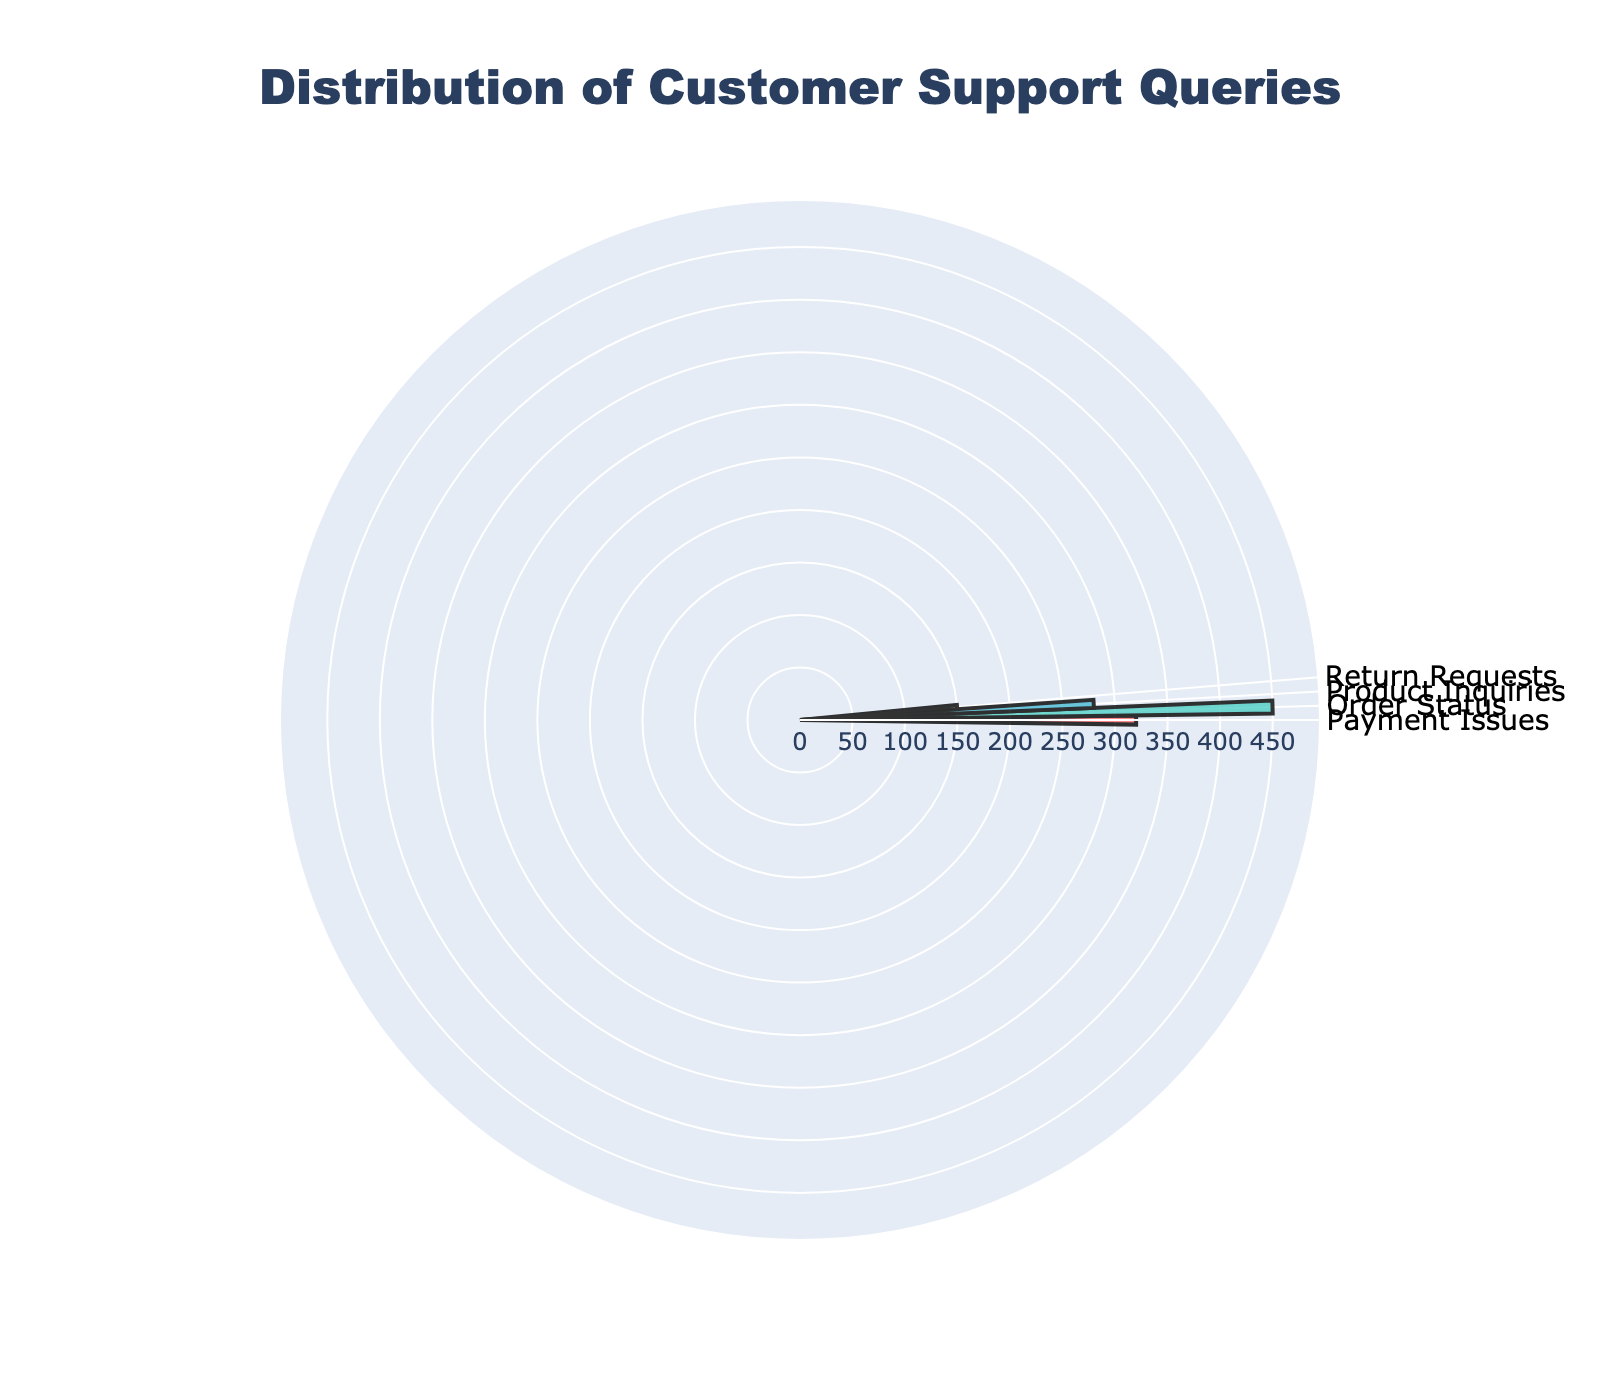How many different issue types are represented in the chart? The figure displays four segments, each corresponding to a different issue type.
Answer: 4 What is the title of the chart? The title is clearly stated at the top of the chart as "Distribution of Customer Support Queries."
Answer: Distribution of Customer Support Queries Which issue type has the highest number of customer support queries? By looking at the lengths of the bars radiating from the center, the "Order Status" segment is the longest.
Answer: Order Status Which issue type has the smallest number of customer support queries? The shortest bar radiating from the center represents "Return Requests."
Answer: Return Requests What is the total number of queries represented in the chart? Summing the query counts for all issue types: 320 (Payment Issues) + 450 (Order Status) + 280 (Product Inquiries) + 150 (Return Requests). 320 + 450 + 280 + 150 = 1200
Answer: 1200 How many more queries does "Order Status" have compared to "Payment Issues"? "Order Status" has 450 queries and "Payment Issues" has 320 queries. 450 - 320 = 130
Answer: 130 What percentage of the total queries does "Product Inquiries" represent? The total number of queries is 1200. "Product Inquiries" has 280 queries. The percentage is (280/1200) * 100 = 23.33%
Answer: 23.33% Which color represents "Return Requests"? The "Return Requests" segment is shown in a color that is a lighter shade, appearing pink-orange. The chart indicates colors distinguishing different issue types, and the lightest one is "Return Requests."
Answer: Pink-orange How do the query counts for "Payment Issues" and "Product Inquiries" compare? The query count for "Payment Issues" is 320, and "Product Inquiries" is 280. 320 is greater than 280.
Answer: Payment Issues > Product Inquiries If the "Order Status" queries were split evenly across four weeks, how many queries per week would there be? "Order Status" has 450 queries. Dividing this by 4 weeks yields 450 / 4 = 112.5. So, each week would have 112 or 113 queries in statistical terms.
Answer: 112.5 